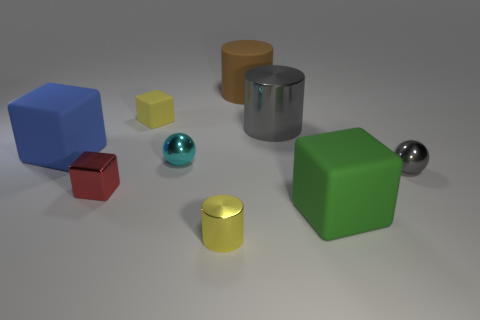Subtract all blue blocks. How many blocks are left? 3 Add 1 gray metal balls. How many objects exist? 10 Subtract 2 cubes. How many cubes are left? 2 Subtract all brown cylinders. How many cylinders are left? 2 Subtract all spheres. How many objects are left? 7 Add 6 matte things. How many matte things are left? 10 Add 9 red metal cubes. How many red metal cubes exist? 10 Subtract 1 red cubes. How many objects are left? 8 Subtract all purple blocks. Subtract all cyan balls. How many blocks are left? 4 Subtract all gray objects. Subtract all gray spheres. How many objects are left? 6 